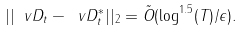Convert formula to latex. <formula><loc_0><loc_0><loc_500><loc_500>| | \ v D _ { t } - \ v D ^ { * } _ { t } | | _ { 2 } = \tilde { O } ( \log ^ { 1 . 5 } ( T ) / \epsilon ) .</formula> 